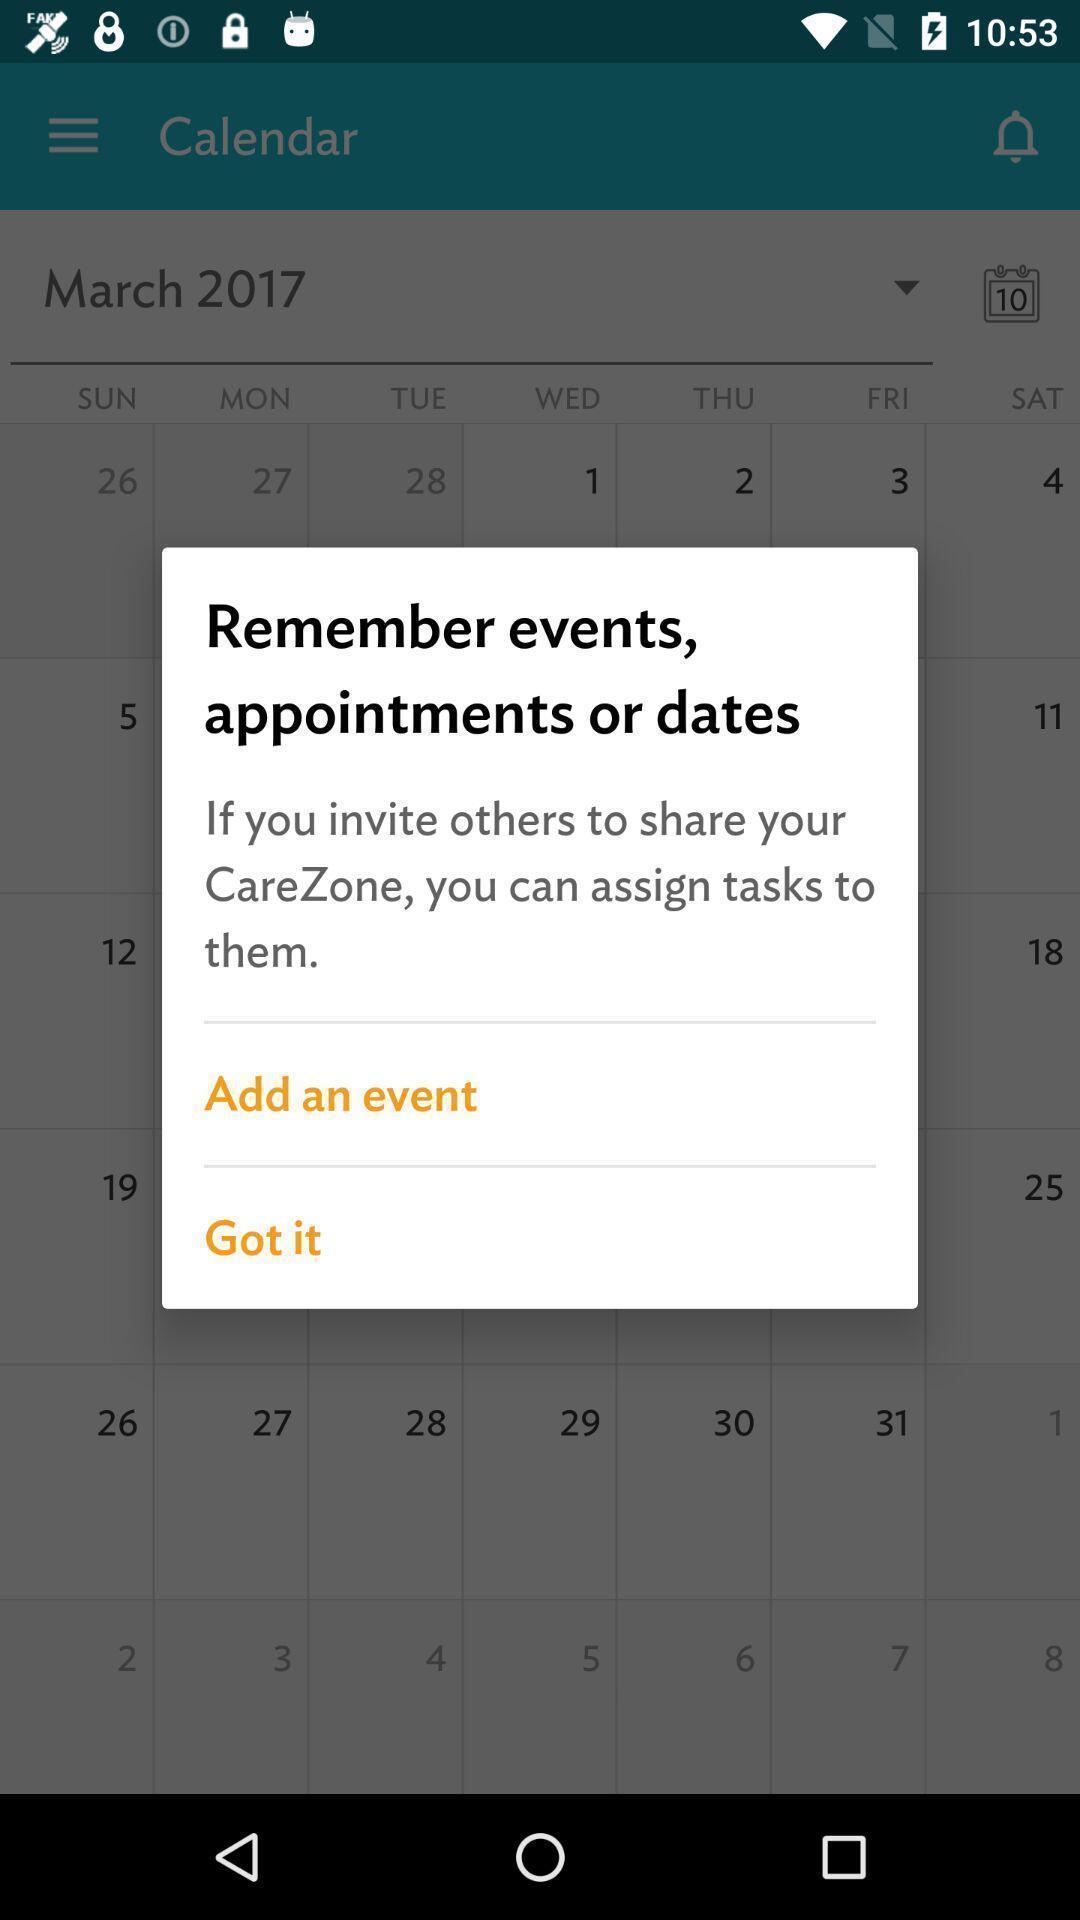What details can you identify in this image? Pop-up displaying to add events. 